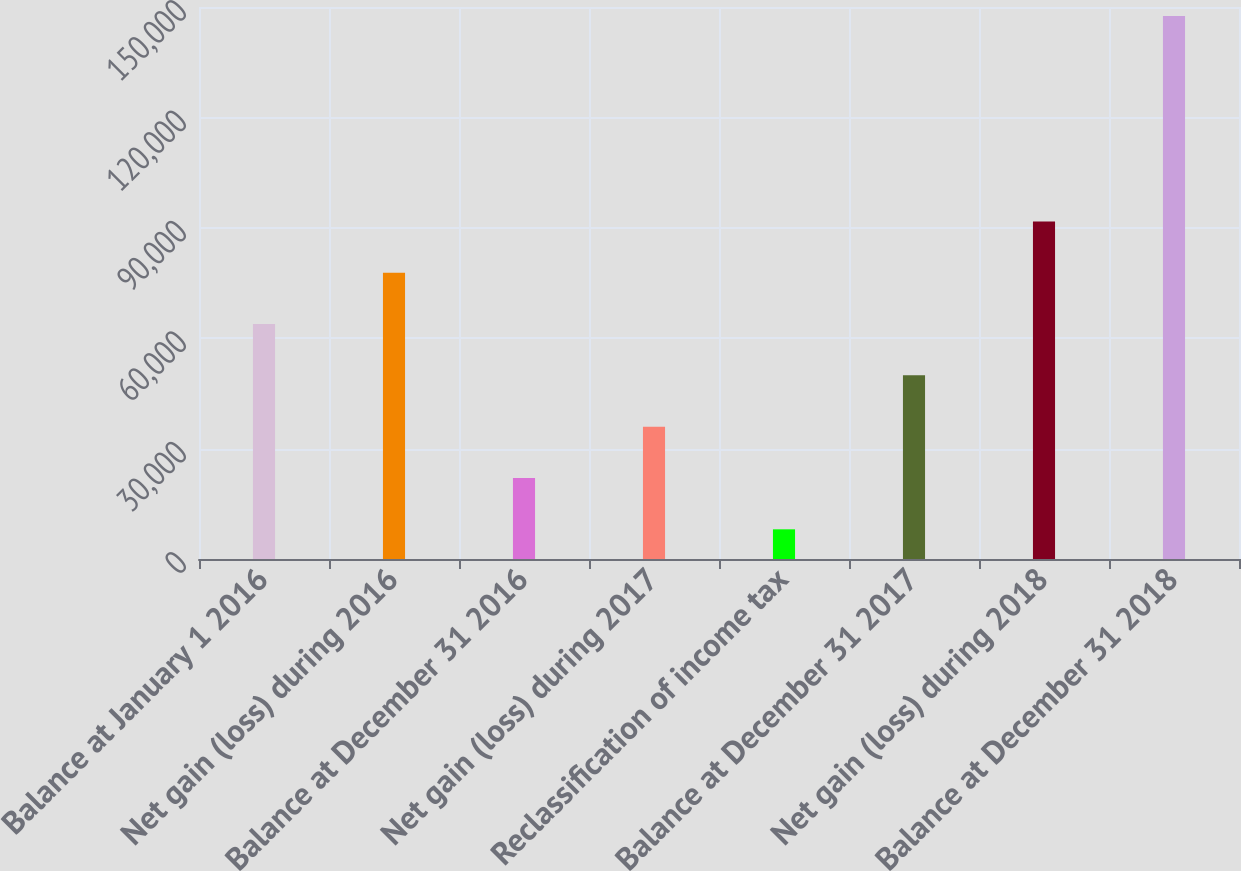<chart> <loc_0><loc_0><loc_500><loc_500><bar_chart><fcel>Balance at January 1 2016<fcel>Net gain (loss) during 2016<fcel>Balance at December 31 2016<fcel>Net gain (loss) during 2017<fcel>Reclassification of income tax<fcel>Balance at December 31 2017<fcel>Net gain (loss) during 2018<fcel>Balance at December 31 2018<nl><fcel>63849.4<fcel>77795.5<fcel>22011.1<fcel>35957.2<fcel>8065<fcel>49903.3<fcel>91741.6<fcel>147526<nl></chart> 